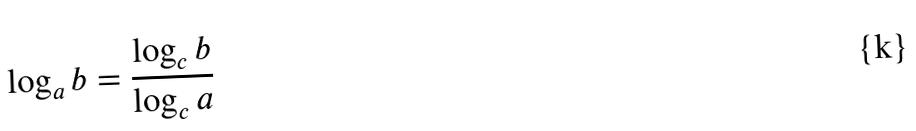Convert formula to latex. <formula><loc_0><loc_0><loc_500><loc_500>\log _ { a } b = \frac { \log _ { c } b } { \log _ { c } a }</formula> 